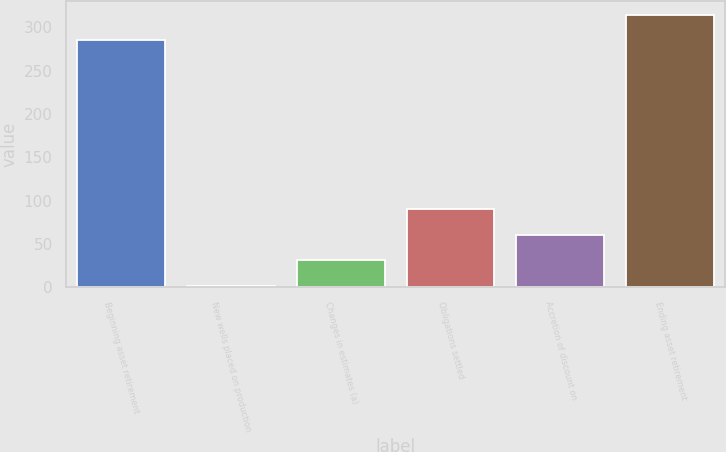Convert chart to OTSL. <chart><loc_0><loc_0><loc_500><loc_500><bar_chart><fcel>Beginning asset retirement<fcel>New wells placed on production<fcel>Changes in estimates (a)<fcel>Obligations settled<fcel>Accretion of discount on<fcel>Ending asset retirement<nl><fcel>285<fcel>2<fcel>31.5<fcel>90.5<fcel>61<fcel>314.5<nl></chart> 